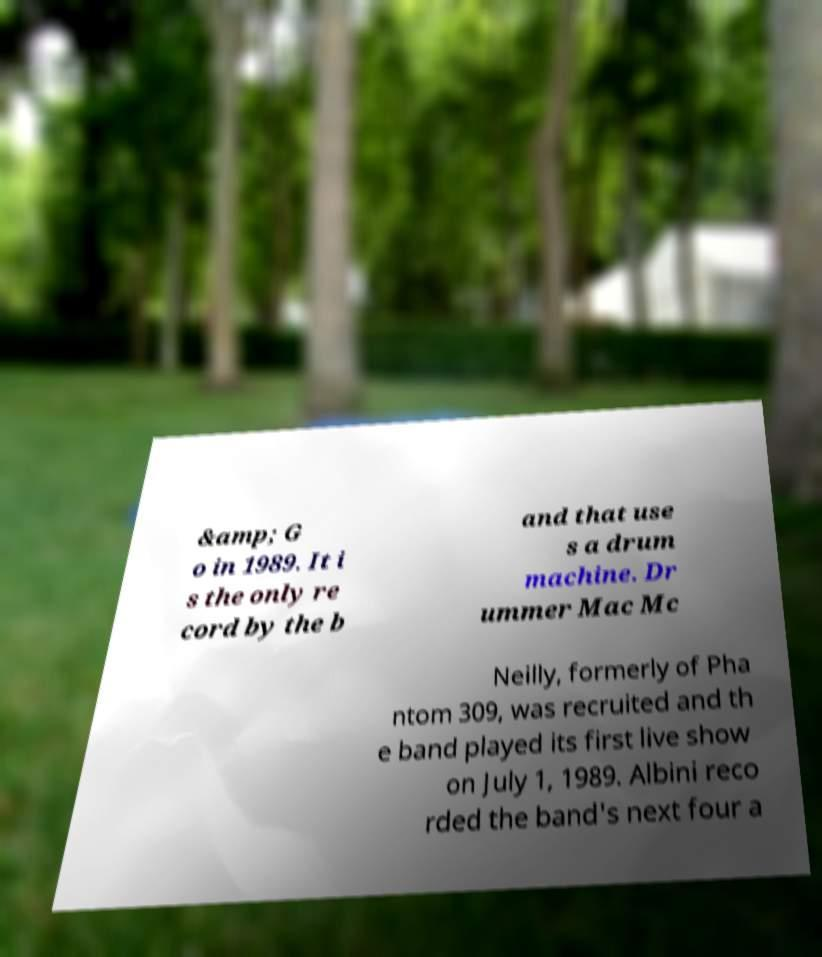What messages or text are displayed in this image? I need them in a readable, typed format. &amp; G o in 1989. It i s the only re cord by the b and that use s a drum machine. Dr ummer Mac Mc Neilly, formerly of Pha ntom 309, was recruited and th e band played its first live show on July 1, 1989. Albini reco rded the band's next four a 